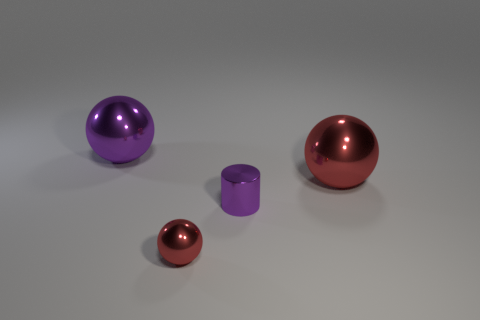What can be inferred about the texture of these objects? The objects in the image appear to have a smooth and shiny texture, indicative of a reflective metal or polished surface. 